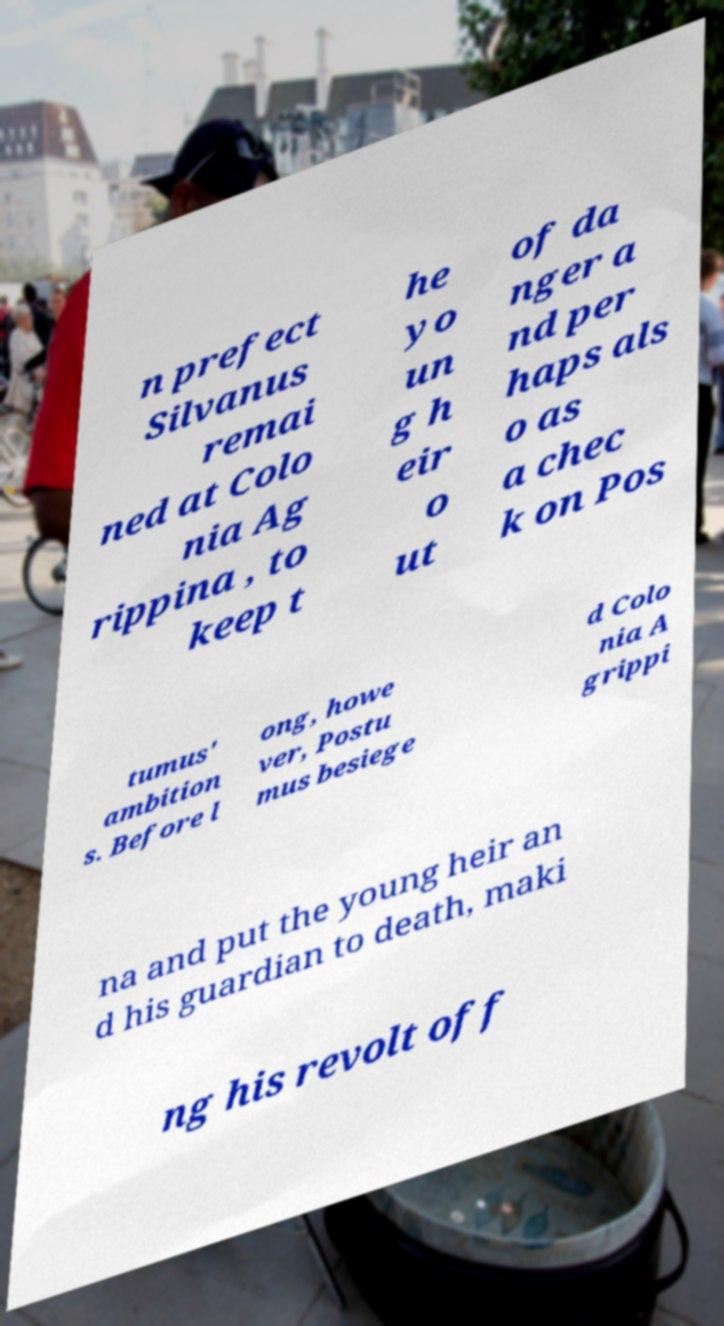Can you read and provide the text displayed in the image?This photo seems to have some interesting text. Can you extract and type it out for me? n prefect Silvanus remai ned at Colo nia Ag rippina , to keep t he yo un g h eir o ut of da nger a nd per haps als o as a chec k on Pos tumus' ambition s. Before l ong, howe ver, Postu mus besiege d Colo nia A grippi na and put the young heir an d his guardian to death, maki ng his revolt off 